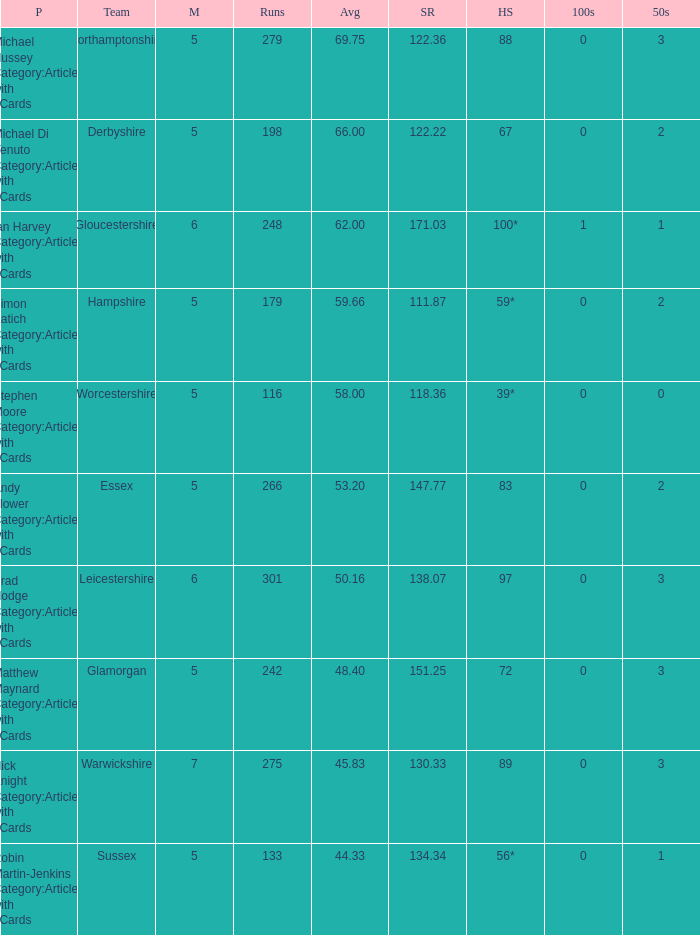What is the smallest amount of matches? 5.0. 